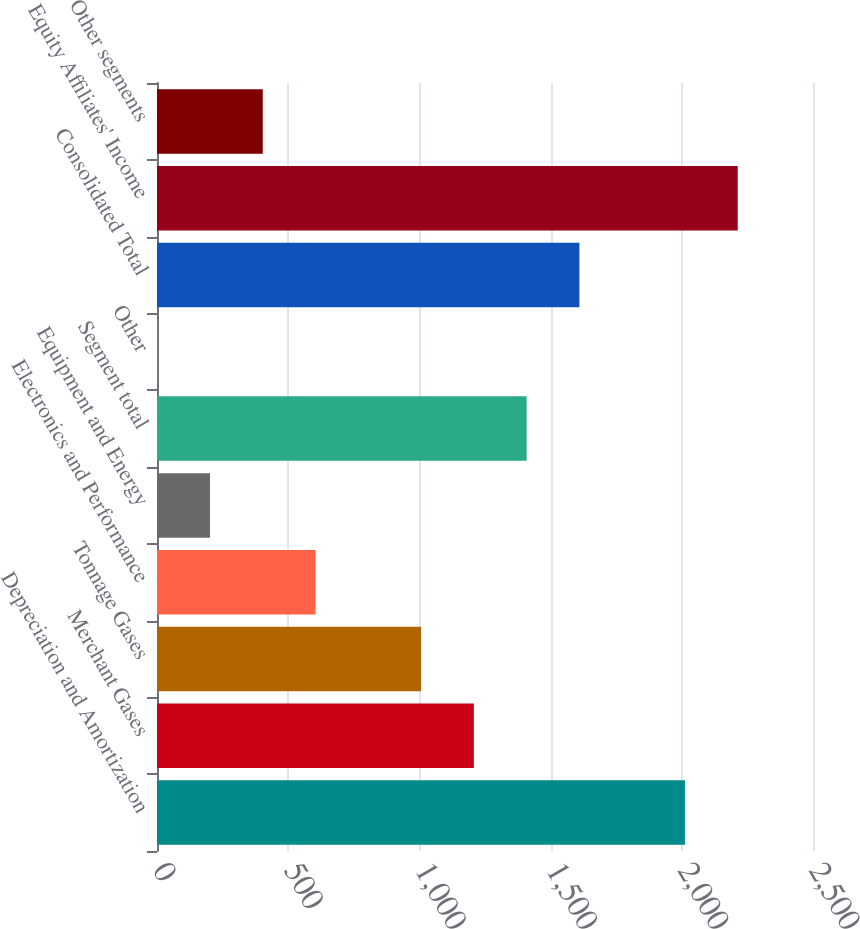Convert chart to OTSL. <chart><loc_0><loc_0><loc_500><loc_500><bar_chart><fcel>Depreciation and Amortization<fcel>Merchant Gases<fcel>Tonnage Gases<fcel>Electronics and Performance<fcel>Equipment and Energy<fcel>Segment total<fcel>Other<fcel>Consolidated Total<fcel>Equity Affiliates' Income<fcel>Other segments<nl><fcel>2012<fcel>1207.56<fcel>1006.45<fcel>604.23<fcel>202.01<fcel>1408.67<fcel>0.9<fcel>1609.78<fcel>2213.11<fcel>403.12<nl></chart> 